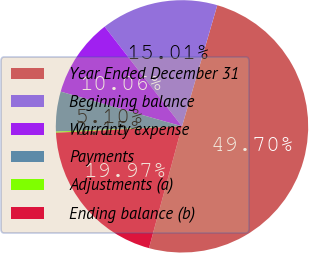<chart> <loc_0><loc_0><loc_500><loc_500><pie_chart><fcel>Year Ended December 31<fcel>Beginning balance<fcel>Warranty expense<fcel>Payments<fcel>Adjustments (a)<fcel>Ending balance (b)<nl><fcel>49.7%<fcel>15.01%<fcel>10.06%<fcel>5.1%<fcel>0.15%<fcel>19.97%<nl></chart> 